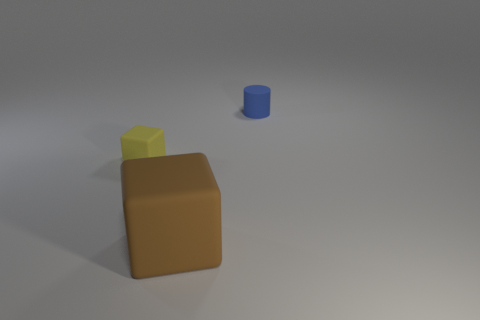Is there any other thing that is the same shape as the blue matte object?
Give a very brief answer. No. Are there any tiny yellow things that have the same material as the large object?
Make the answer very short. Yes. Is the number of big brown cubes on the left side of the big brown block less than the number of tiny rubber cylinders?
Your answer should be very brief. Yes. Is the size of the rubber cube left of the brown matte block the same as the brown matte object?
Your answer should be compact. No. How many big brown things are the same shape as the small yellow matte thing?
Make the answer very short. 1. The brown cube that is made of the same material as the yellow thing is what size?
Your answer should be compact. Large. Is the number of tiny yellow rubber blocks that are behind the big rubber cube the same as the number of blocks?
Provide a succinct answer. No. Does the tiny matte block have the same color as the big rubber object?
Offer a very short reply. No. Is the shape of the small matte object on the left side of the big cube the same as the thing in front of the tiny rubber block?
Your answer should be compact. Yes. There is a tiny thing that is the same shape as the big matte object; what material is it?
Your answer should be compact. Rubber. 